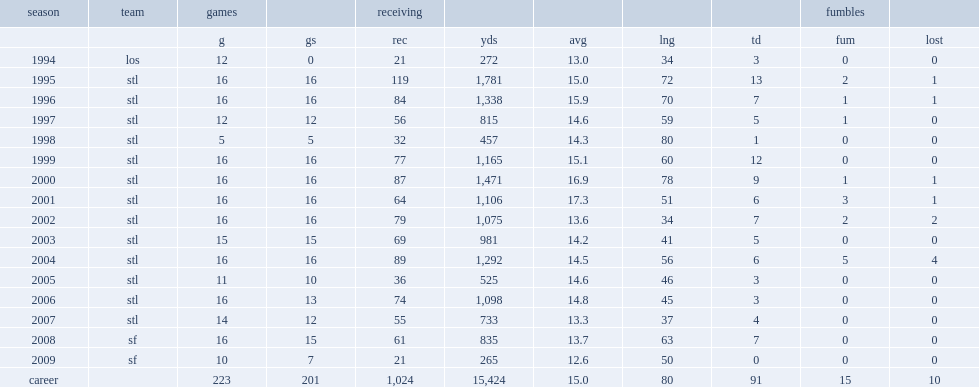How many receiving yards did bruce get in 2003? 981.0. How many receptions did bruce get in 1995? 119.0. 